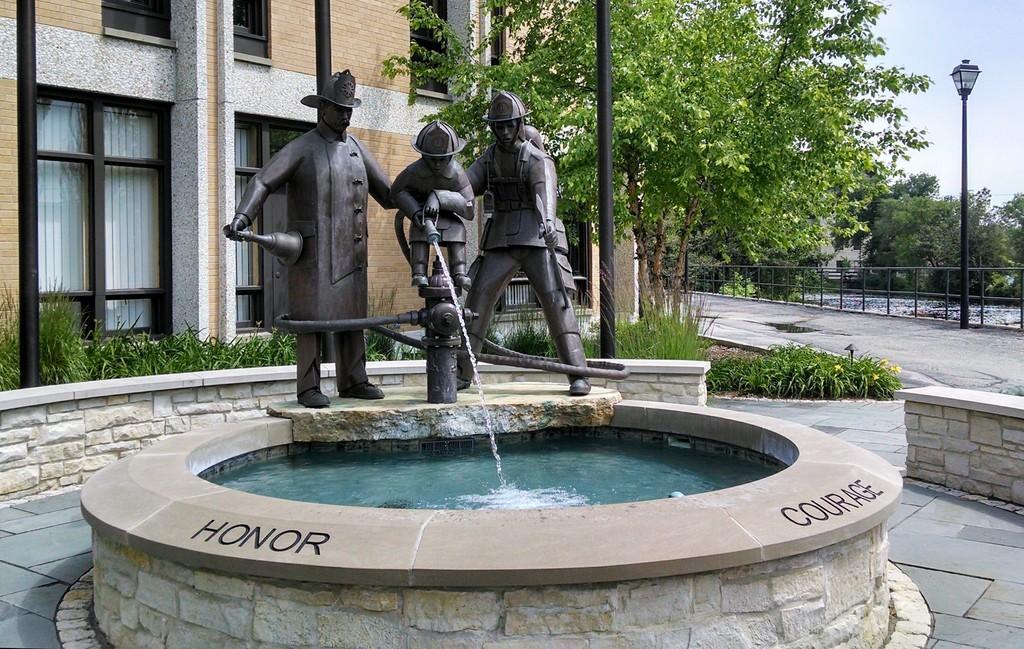How would you summarize this image in a sentence or two? In this image I can see a water pond in the front and on it I can see few statues, in the front of it I can see something is written on the left and on the right side. In the background I can see plants, number of trees, few poles, a building, a light, railing and the sky. 